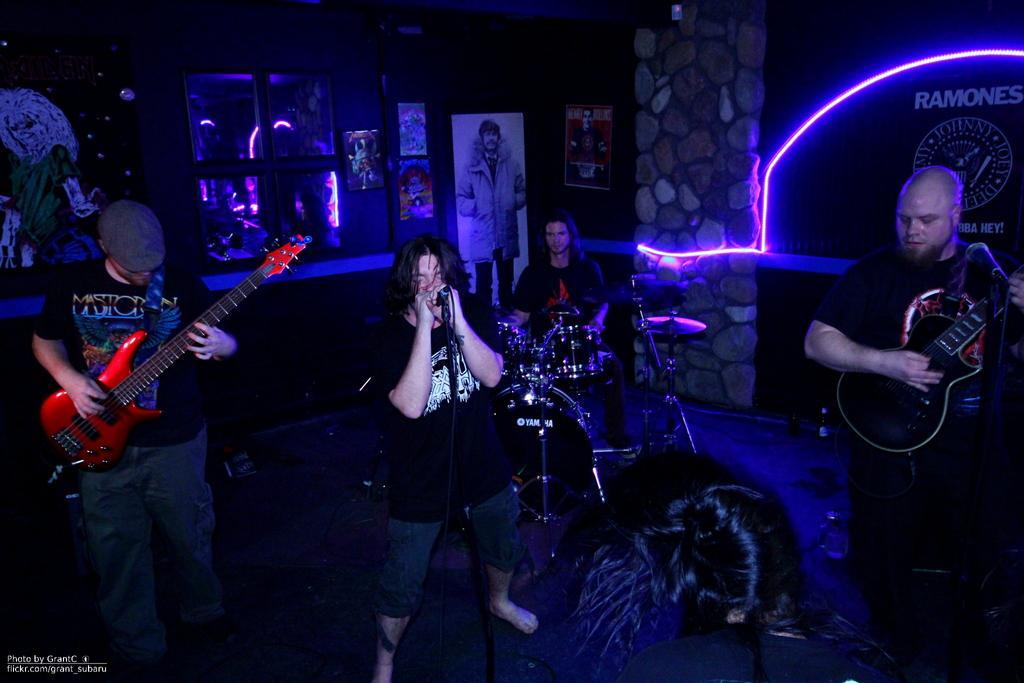Can you describe this image briefly? It looks like the picture is taken inside a club, there are a group of people playing music instruments and among them one person is singing a song, behind them there are some posters attached to the background and on the right side there is a light and the light is being reflected on the window in the background. 